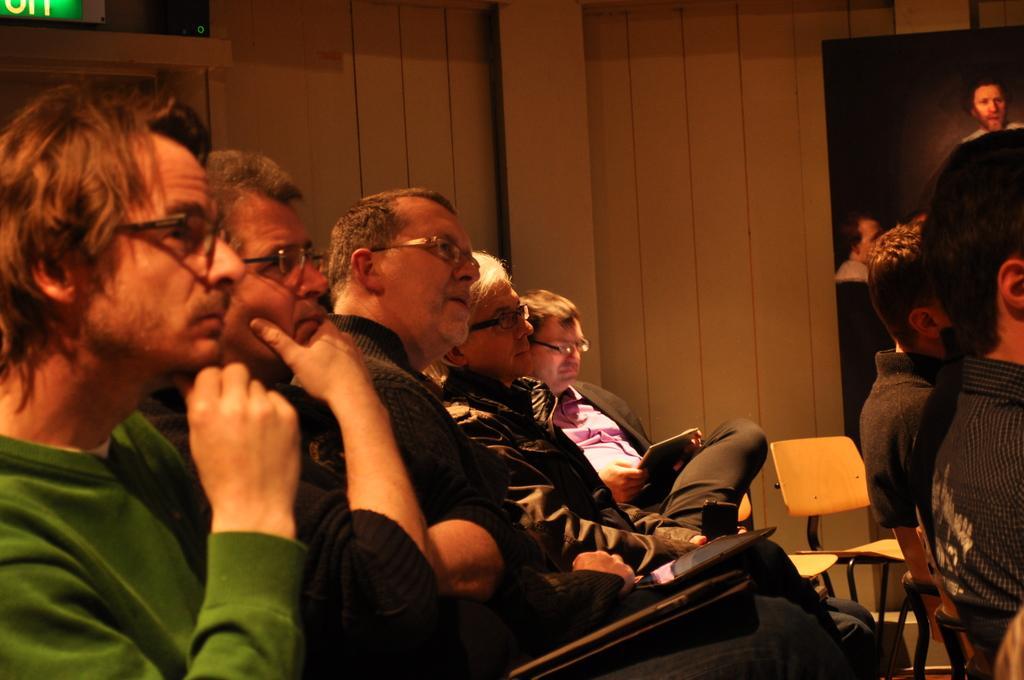Can you describe this image briefly? In this image On the left there are two men sitting on the chairs. On the left there is a man he wear green t shirt and spectacles. In the middle there are two empty chairs. In the background there is a poster and wall. 